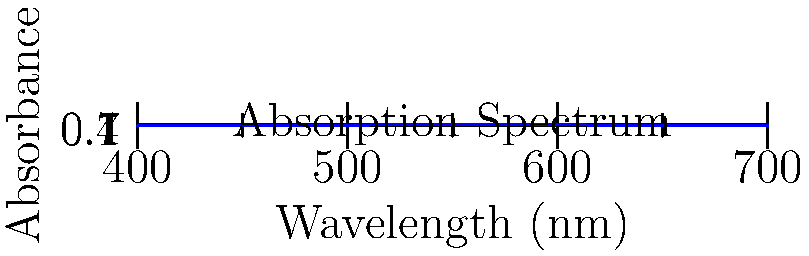Based on the absorption spectrum shown in the graph, which wavelength would be most appropriate for conducting a colorimetric analysis of phosphorus in soil samples using the molybdenum blue method? To determine the most appropriate wavelength for colorimetric analysis of phosphorus using the molybdenum blue method, we need to follow these steps:

1. Understand the principle: The molybdenum blue method for phosphorus analysis relies on the formation of a blue-colored complex that absorbs light most strongly in the red region of the visible spectrum.

2. Analyze the graph: The absorption spectrum shows the relationship between wavelength and absorbance. The peak of the curve represents the wavelength at which the sample absorbs light most strongly.

3. Identify the peak: In this graph, the maximum absorbance occurs at approximately 550 nm.

4. Consider the color wheel: The wavelength of 550 nm corresponds to the green-yellow region of the visible spectrum. The complementary color to green-yellow is blue-violet.

5. Match with the molybdenum blue complex: Since the molybdenum blue complex appears blue, it absorbs light most strongly in the red-orange region of the spectrum, which is around 600-650 nm.

6. Select the appropriate wavelength: Based on the graph and the principles of colorimetry, the most suitable wavelength for this analysis would be around 650 nm, where there is still significant absorbance for the blue complex.

Therefore, the most appropriate wavelength for conducting a colorimetric analysis of phosphorus in soil samples using the molybdenum blue method would be 650 nm.
Answer: 650 nm 